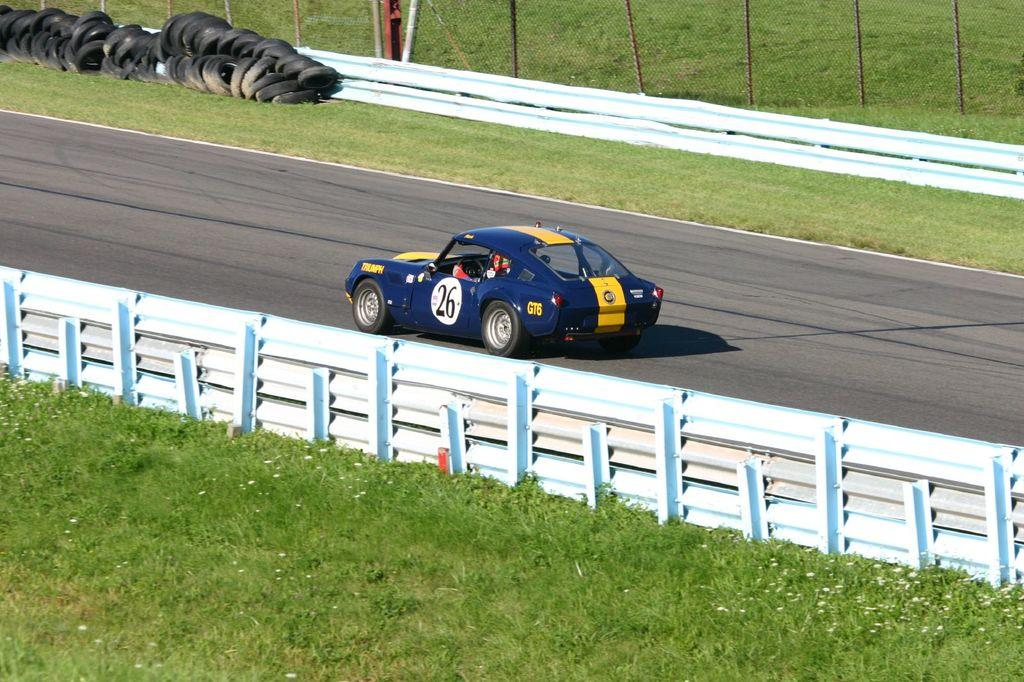What type of vehicle can be seen on the road in the image? There is a car on the road in the image. What is the barrier that separates the road from the grassy area? There is a fence in the image, which includes a metal fence. What type of vegetation is present in the image? Grass and plants are visible in the image. What objects are grouped together in the image? There is a group of tires in the image. What vertical structure can be seen in the image? There is a pole in the image. What company is responsible for the thrilling experience depicted in the image? There is no specific company or thrilling experience mentioned or depicted in the image. 